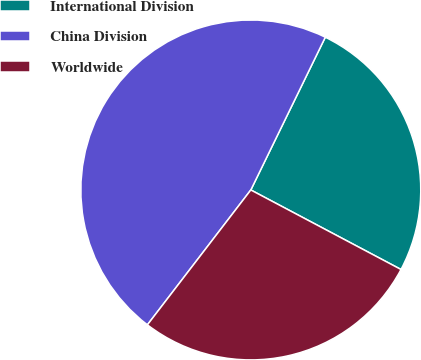<chart> <loc_0><loc_0><loc_500><loc_500><pie_chart><fcel>International Division<fcel>China Division<fcel>Worldwide<nl><fcel>25.53%<fcel>46.81%<fcel>27.66%<nl></chart> 